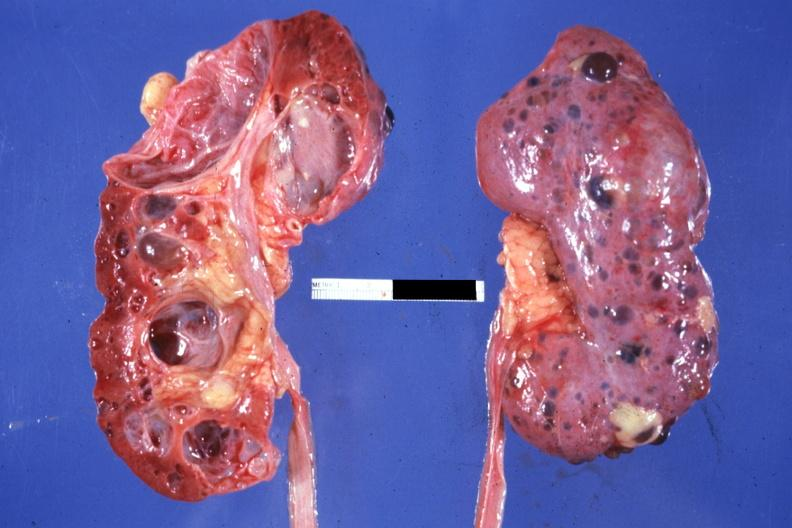where is this?
Answer the question using a single word or phrase. Urinary 